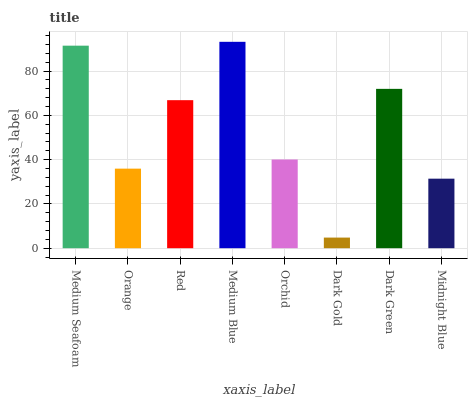Is Dark Gold the minimum?
Answer yes or no. Yes. Is Medium Blue the maximum?
Answer yes or no. Yes. Is Orange the minimum?
Answer yes or no. No. Is Orange the maximum?
Answer yes or no. No. Is Medium Seafoam greater than Orange?
Answer yes or no. Yes. Is Orange less than Medium Seafoam?
Answer yes or no. Yes. Is Orange greater than Medium Seafoam?
Answer yes or no. No. Is Medium Seafoam less than Orange?
Answer yes or no. No. Is Red the high median?
Answer yes or no. Yes. Is Orchid the low median?
Answer yes or no. Yes. Is Medium Blue the high median?
Answer yes or no. No. Is Medium Seafoam the low median?
Answer yes or no. No. 